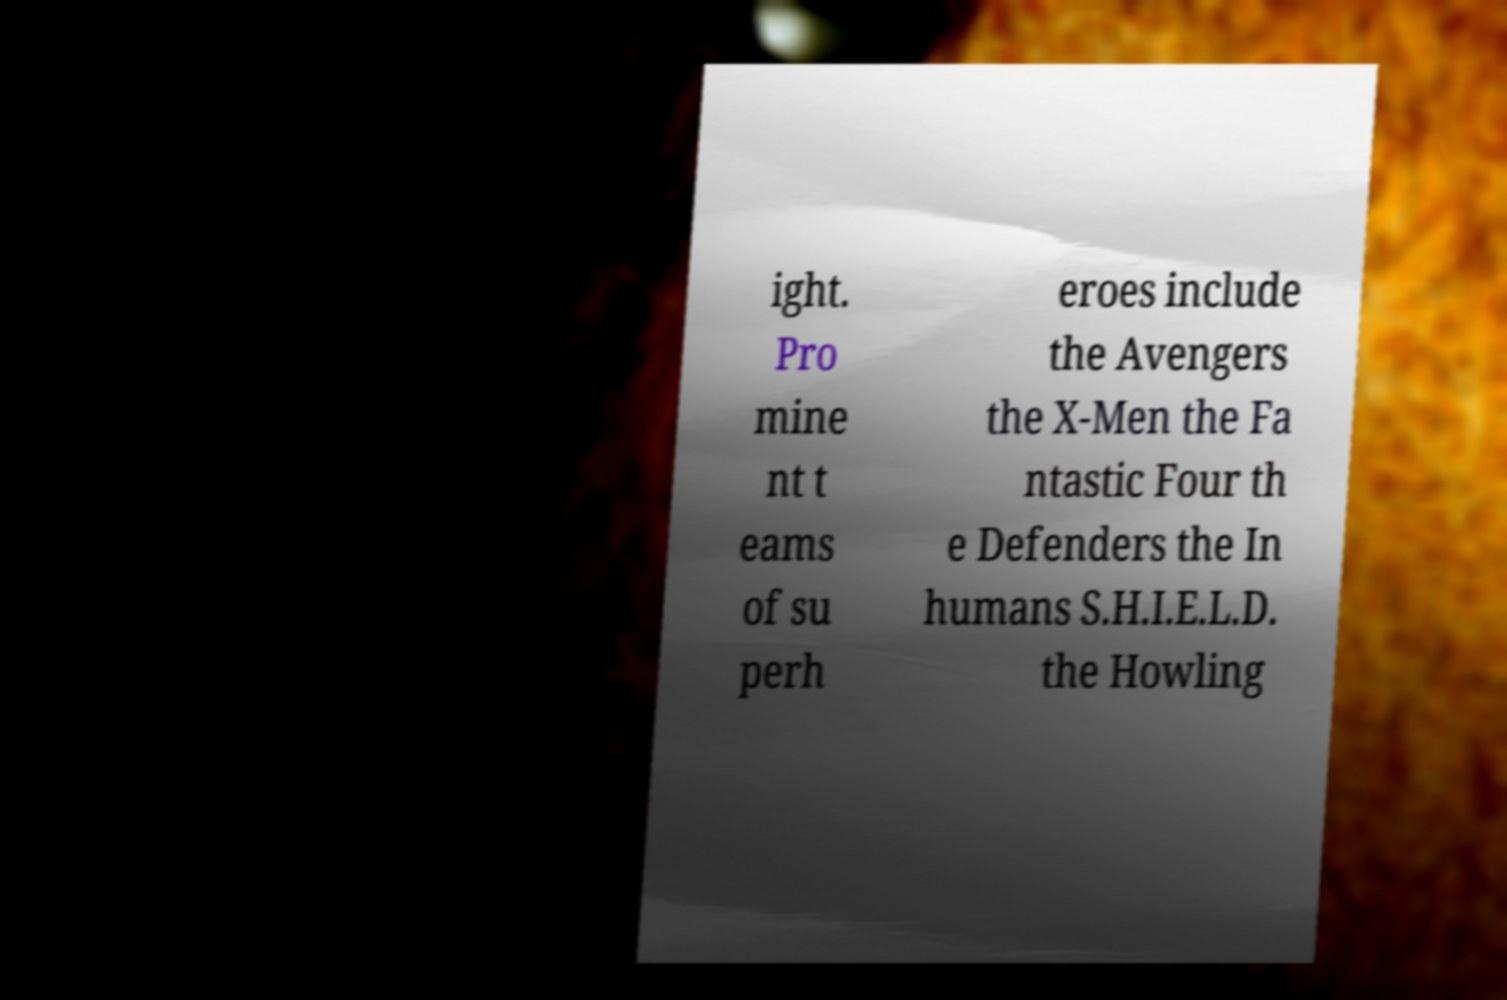Please read and relay the text visible in this image. What does it say? ight. Pro mine nt t eams of su perh eroes include the Avengers the X-Men the Fa ntastic Four th e Defenders the In humans S.H.I.E.L.D. the Howling 